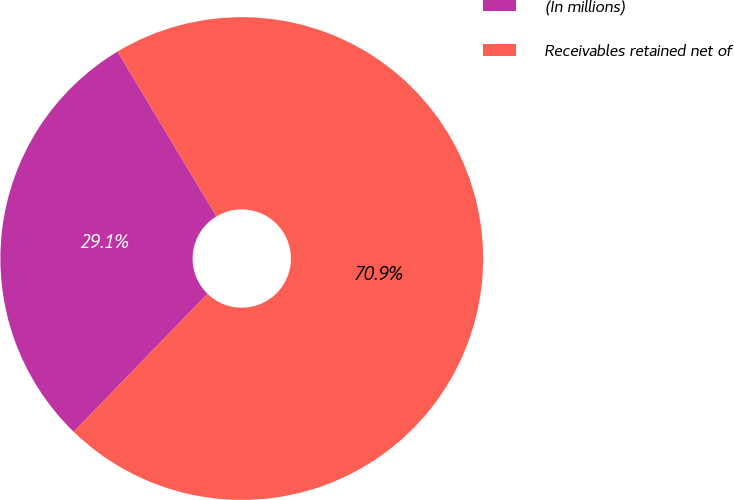<chart> <loc_0><loc_0><loc_500><loc_500><pie_chart><fcel>(In millions)<fcel>Receivables retained net of<nl><fcel>29.14%<fcel>70.86%<nl></chart> 